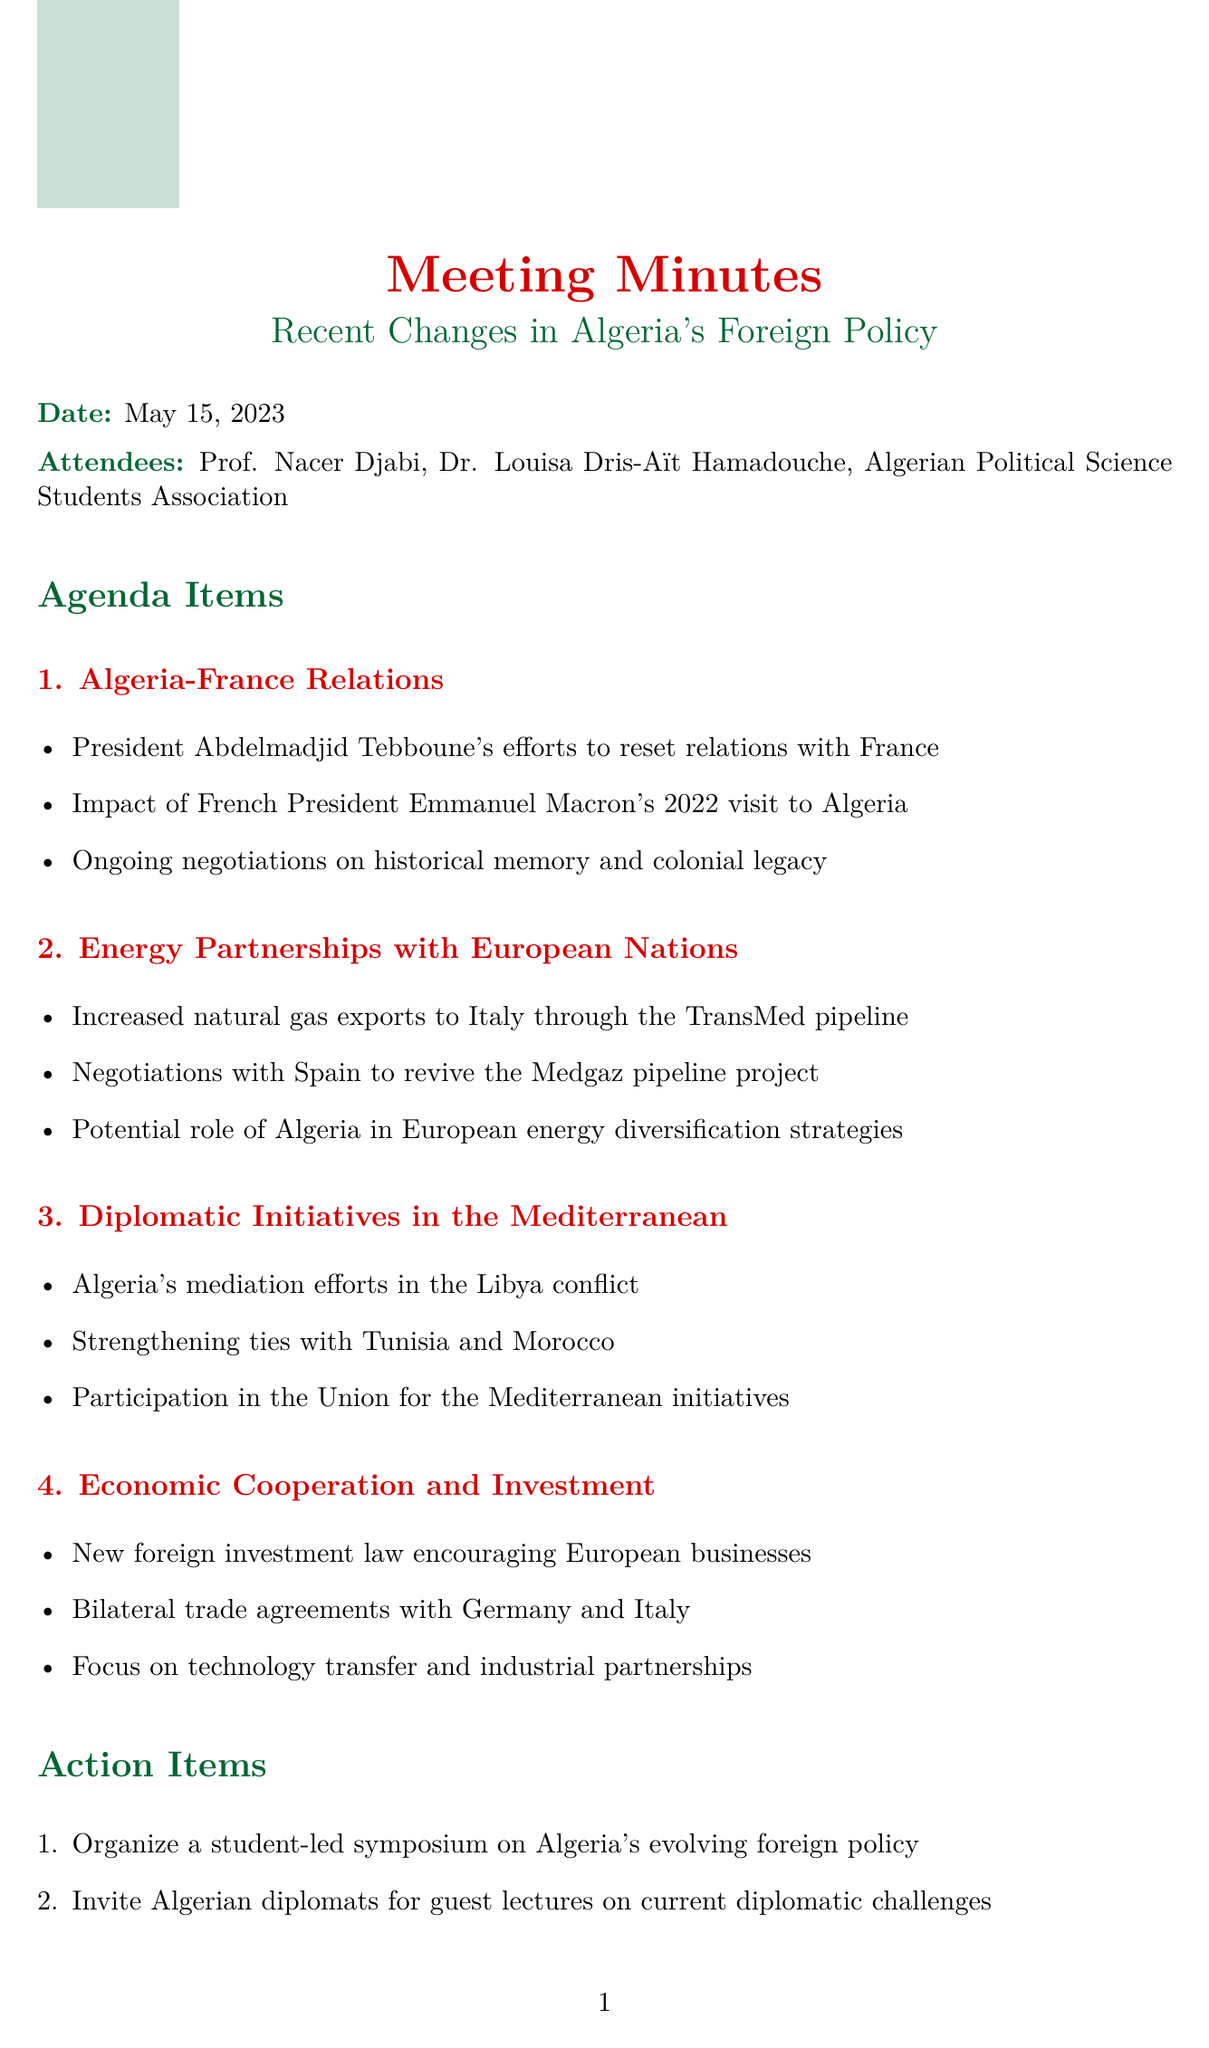What is the title of the meeting? The title of the meeting is explicitly stated at the top of the document.
Answer: Recent Changes in Algeria's Foreign Policy Who attended the meeting? The attendees section lists the individuals and associations present at the meeting.
Answer: Prof. Nacer Djabi, Dr. Louisa Dris-Aït Hamadouche, Algerian Political Science Students Association What is the date of the next meeting? The document specifies the date of the next meeting in the last section.
Answer: June 12, 2023 What initiative is Algeria undertaking regarding Libya? The document mentions Algeria's involvement in mediating the conflict in Libya.
Answer: Algeria's mediation efforts in the Libya conflict Which pipeline project is being revived with Spain? The key points list negotiations for the specific energy project with Spain.
Answer: Medgaz pipeline project How many agenda items were discussed? The agenda items are clearly enumerated in the document, providing the total count.
Answer: Four What type of law is encouraging European businesses in Algeria? The document specifies the nature of the law aimed at foreign investment.
Answer: New foreign investment law Which country was the focus of increased natural gas exports? The details in the agenda clearly identify the target country for exports.
Answer: Italy 